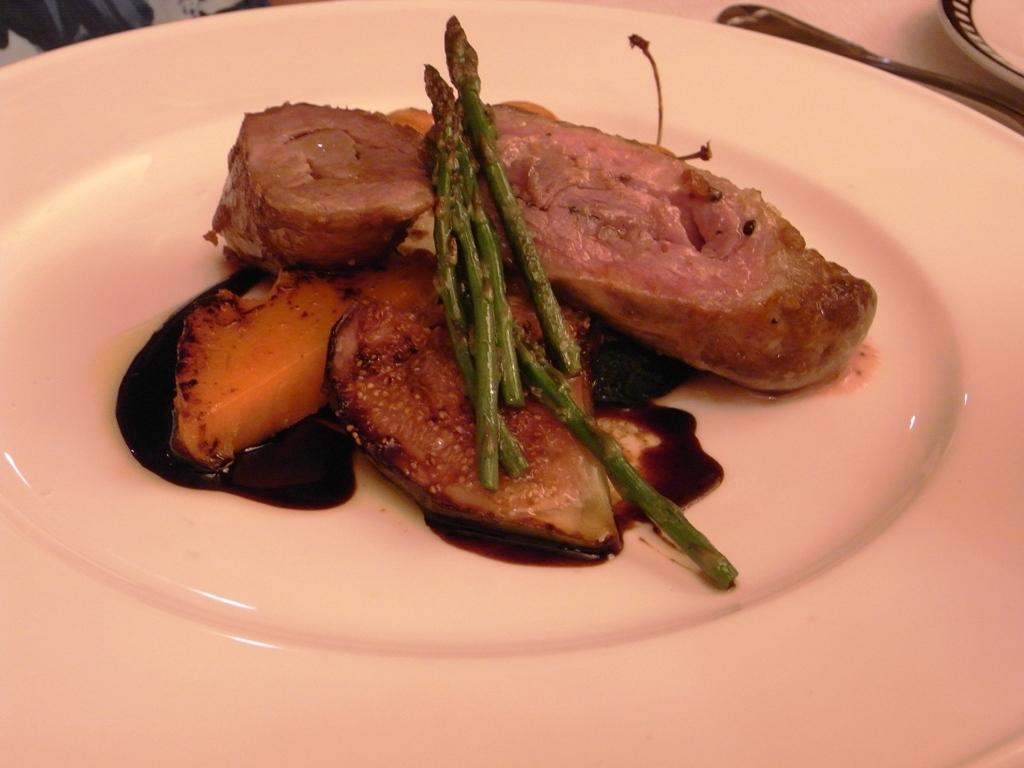What type of dishware can be seen in the image? There are plates in the image. What else is present on the plates? There is food in the image. Can you describe the unspecified object in the image? Unfortunately, the facts provided do not give any details about the unspecified object. What type of wax can be seen melting on the plates in the image? There is no wax present in the image; it only mentions plates and food. 